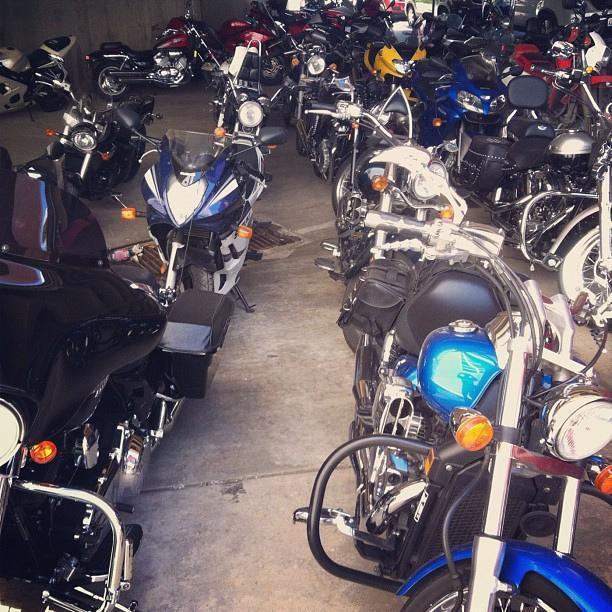How many motorcycles are there?
Give a very brief answer. 11. 